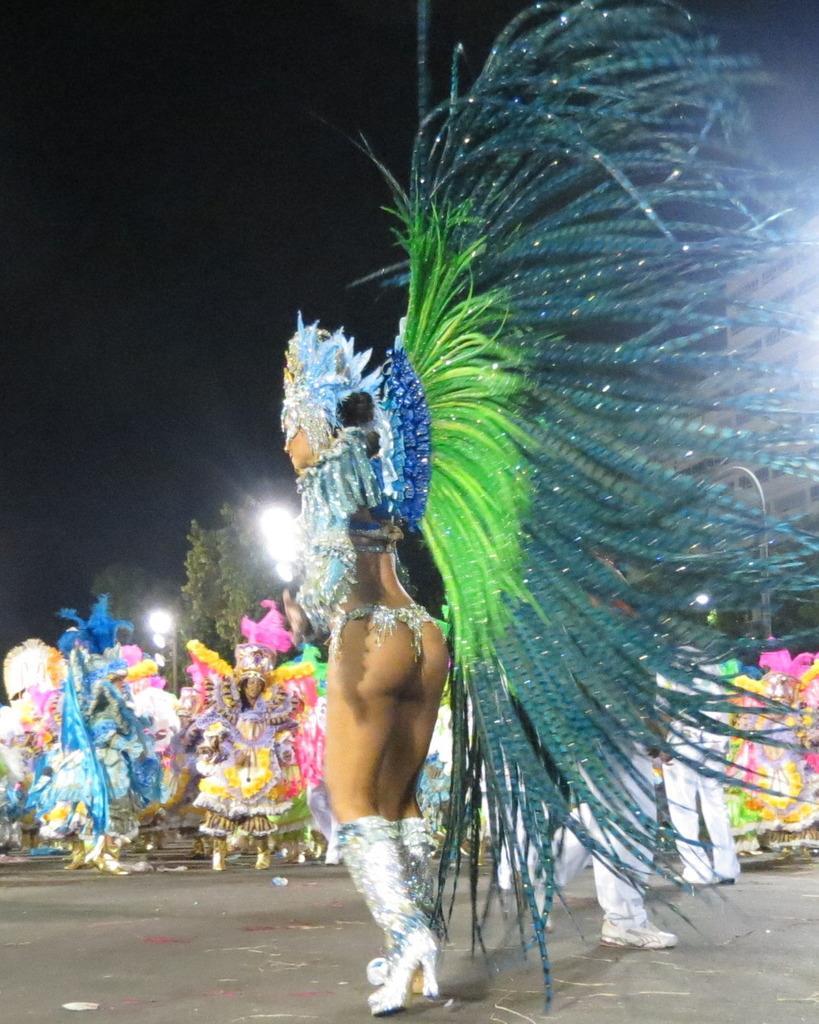Describe this image in one or two sentences. In this image there is one person's standing and wearing a carnival dress as we can see in the middle of this image. There are some other persons standing in the background. There are some trees in the middle of this image. There is a sky on the top of this image. 